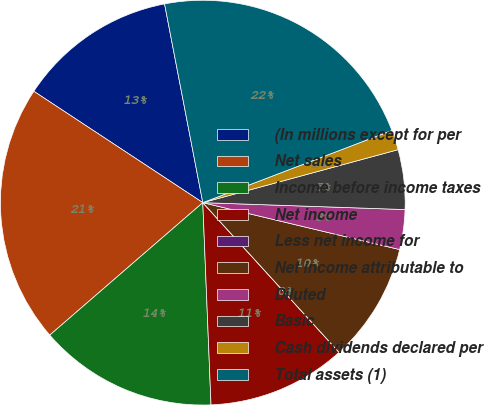<chart> <loc_0><loc_0><loc_500><loc_500><pie_chart><fcel>(In millions except for per<fcel>Net sales<fcel>Income before income taxes<fcel>Net income<fcel>Less net income for<fcel>Net income attributable to<fcel>Diluted<fcel>Basic<fcel>Cash dividends declared per<fcel>Total assets (1)<nl><fcel>12.7%<fcel>20.63%<fcel>14.29%<fcel>11.11%<fcel>0.0%<fcel>9.52%<fcel>3.18%<fcel>4.76%<fcel>1.59%<fcel>22.22%<nl></chart> 